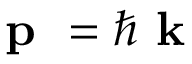<formula> <loc_0><loc_0><loc_500><loc_500>p = \hbar { k }</formula> 